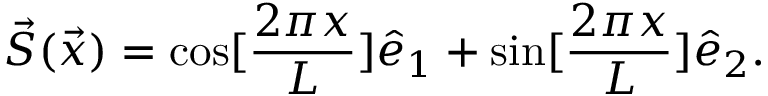<formula> <loc_0><loc_0><loc_500><loc_500>\vec { S } ( \vec { x } ) = \cos [ \frac { 2 \pi x } { L } ] \hat { e } _ { 1 } + \sin [ \frac { 2 \pi x } { L } ] \hat { e } _ { 2 } .</formula> 